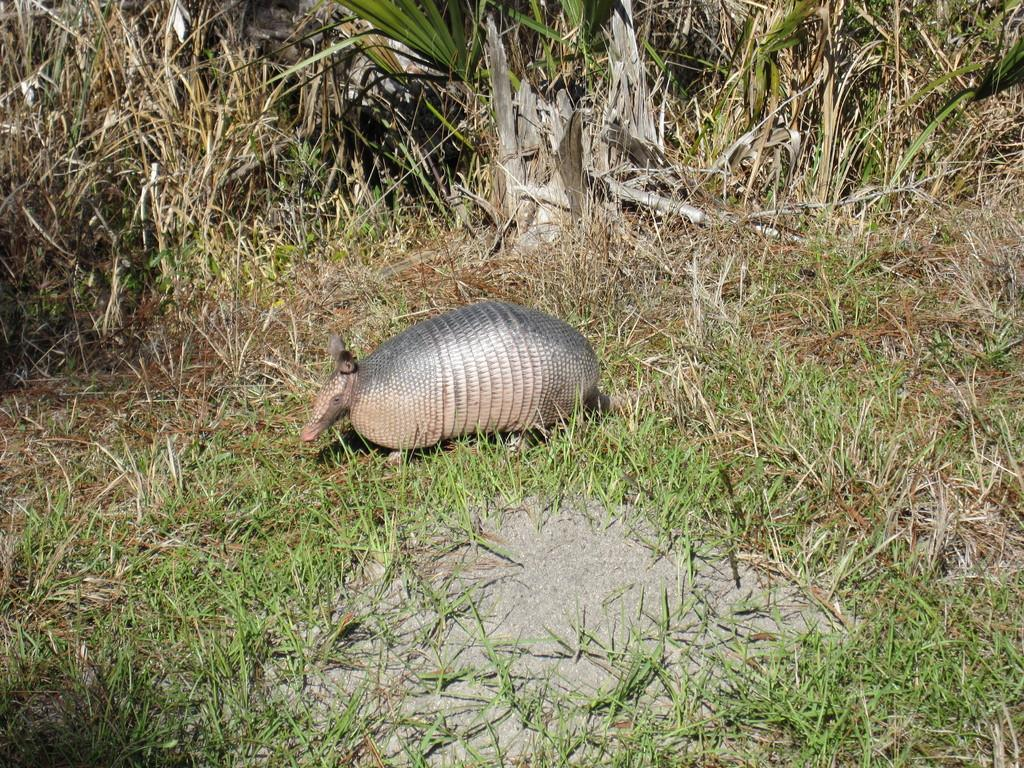What type of creature is in the image? There is an animal in the image. Where is the animal located? The animal is on the grass. What other living organisms can be seen in the image? There are plants in the image. What type of books can be seen in the animal's paws in the image? There are no books present in the image, and the animal does not have any paws. 